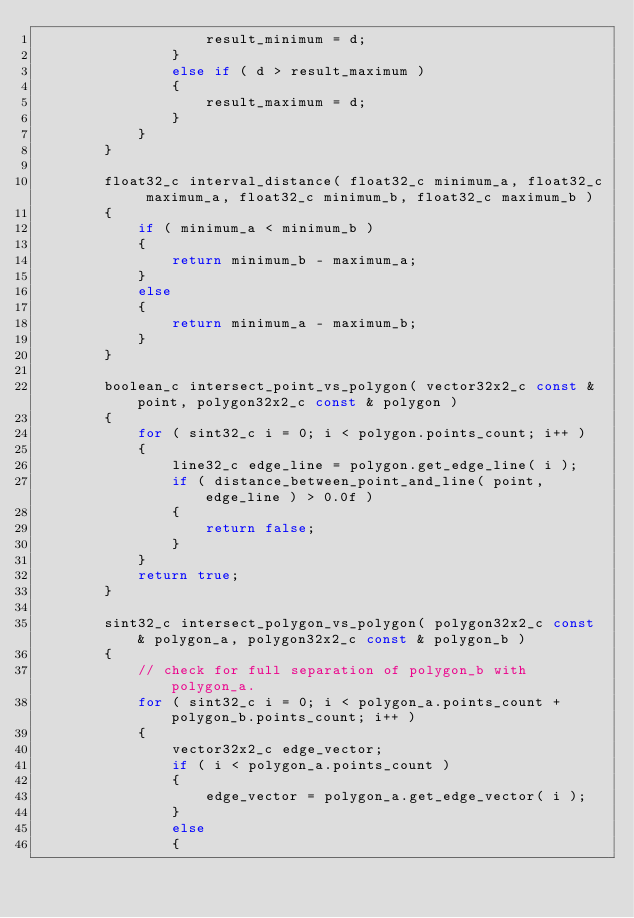Convert code to text. <code><loc_0><loc_0><loc_500><loc_500><_C++_>					result_minimum = d;
				}
				else if ( d > result_maximum )
				{
					result_maximum = d;
				}
			}
		}

		float32_c interval_distance( float32_c minimum_a, float32_c maximum_a, float32_c minimum_b, float32_c maximum_b )
		{
			if ( minimum_a < minimum_b )
			{
				return minimum_b - maximum_a;
			}
			else
			{
				return minimum_a - maximum_b;
			}
		}

		boolean_c intersect_point_vs_polygon( vector32x2_c const & point, polygon32x2_c const & polygon )
		{
			for ( sint32_c i = 0; i < polygon.points_count; i++ )
			{
				line32_c edge_line = polygon.get_edge_line( i );
				if ( distance_between_point_and_line( point, edge_line ) > 0.0f )
				{
					return false;
				}
			}
			return true;
		}

		sint32_c intersect_polygon_vs_polygon( polygon32x2_c const & polygon_a, polygon32x2_c const & polygon_b )
		{
			// check for full separation of polygon_b with polygon_a.
			for ( sint32_c i = 0; i < polygon_a.points_count + polygon_b.points_count; i++ )
			{
				vector32x2_c edge_vector;
				if ( i < polygon_a.points_count )
				{
					edge_vector = polygon_a.get_edge_vector( i );
				}
				else
				{</code> 